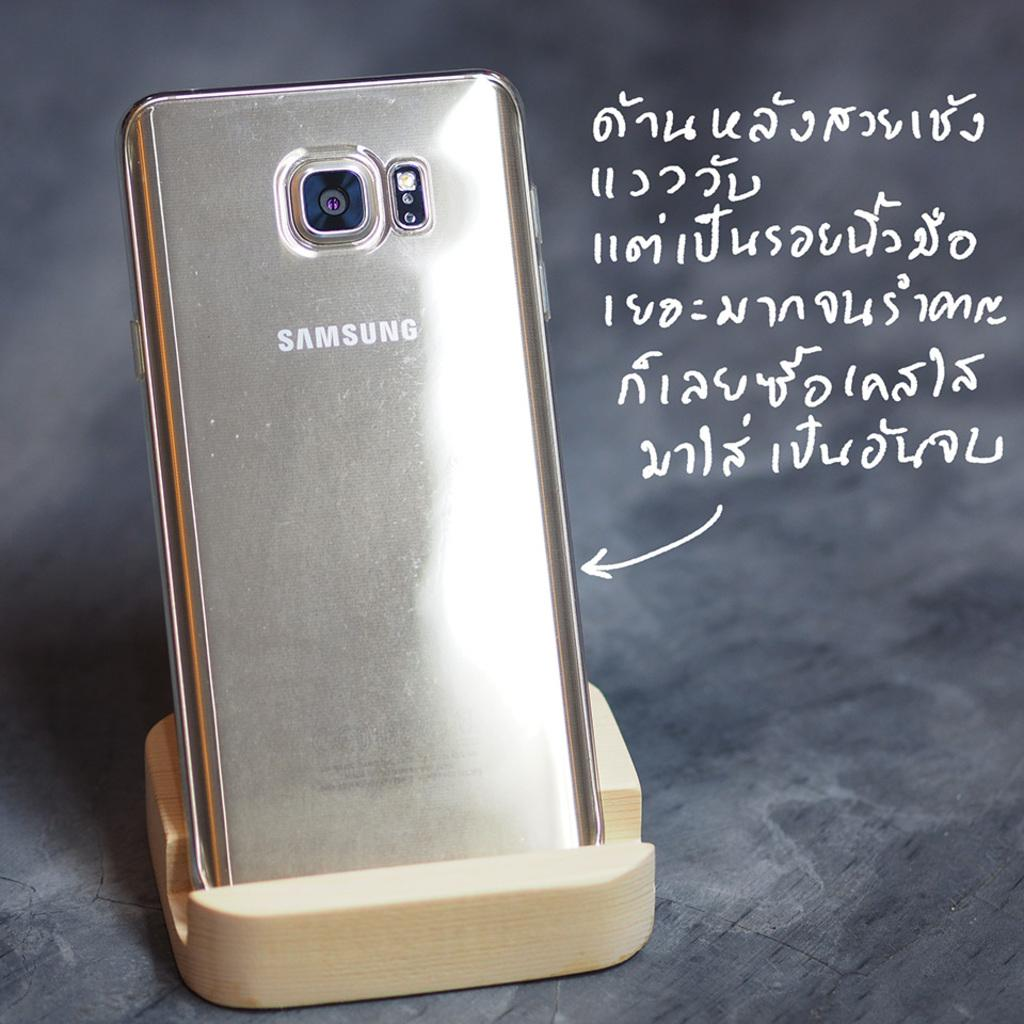<image>
Relay a brief, clear account of the picture shown. a shiny metal Samsung phone on a display pedestal next to Thai words 